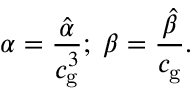Convert formula to latex. <formula><loc_0><loc_0><loc_500><loc_500>\alpha = \frac { \hat { \alpha } } { c _ { g } ^ { 3 } } ; \, \beta = \frac { \hat { \beta } } { c _ { g } } .</formula> 